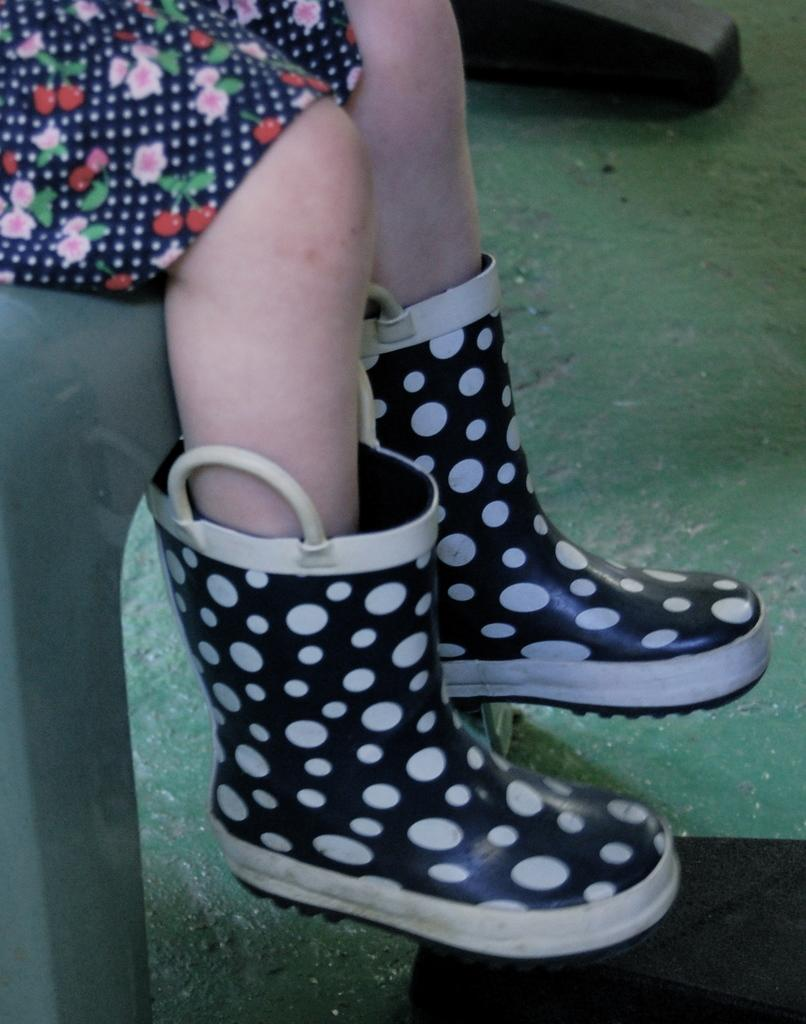What body parts of the girls can be seen in the image? There are girls' legs visible in the image. What are the girls wearing on their feet? The girls are wearing shoes. What are the girls sitting on in the image? The girls are sitting on a chair. What is the surface beneath the girls in the image? There is a floor at the bottom of the image. What type of rice is being served on the girls' plates in the image? There is no rice or plates present in the image; it only shows girls' legs, shoes, and a chair. 